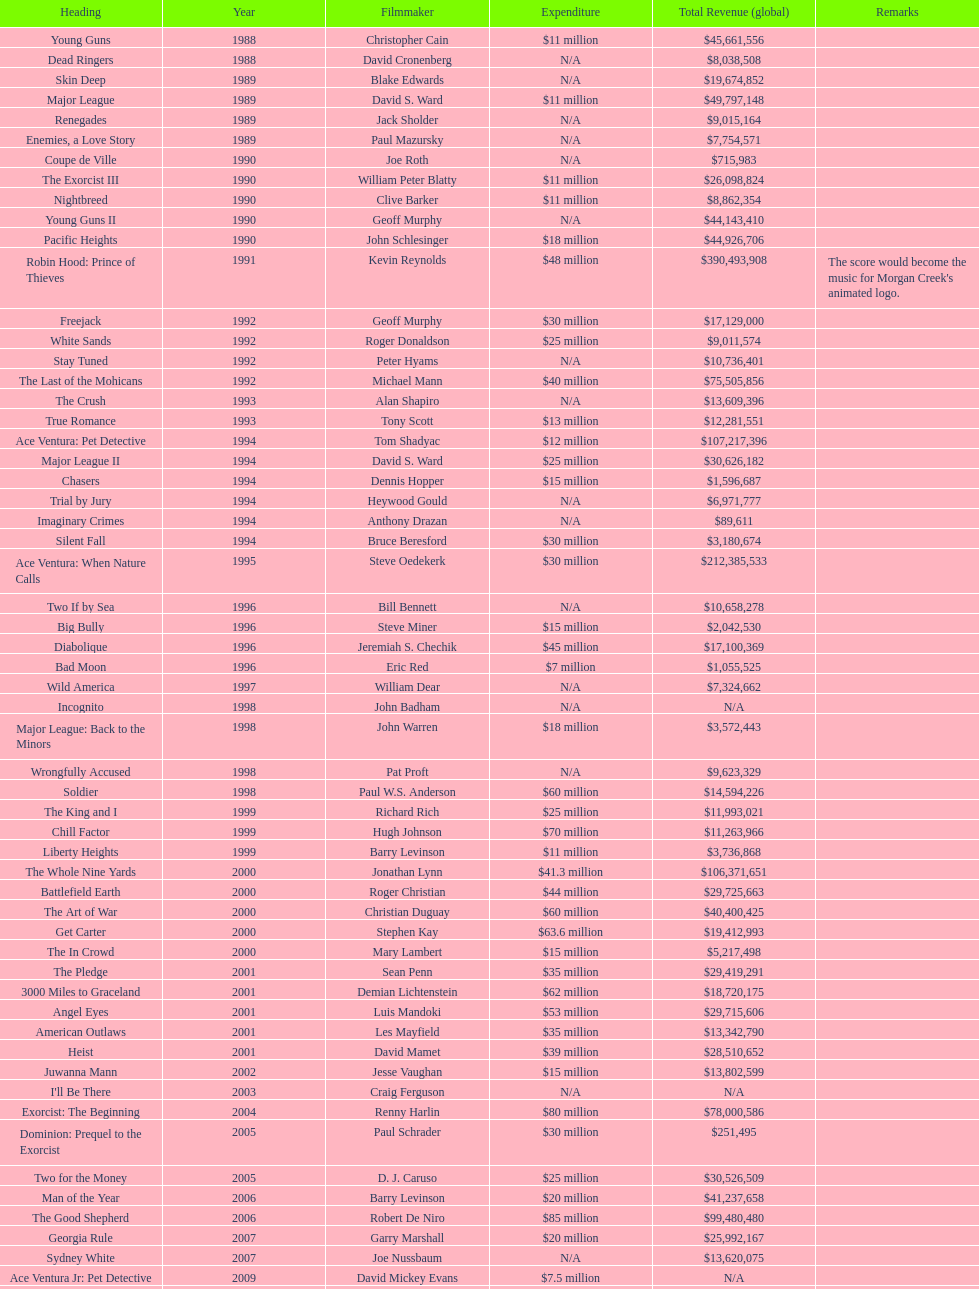What is the sole movie that had a 48-million-dollar budget? Robin Hood: Prince of Thieves. 